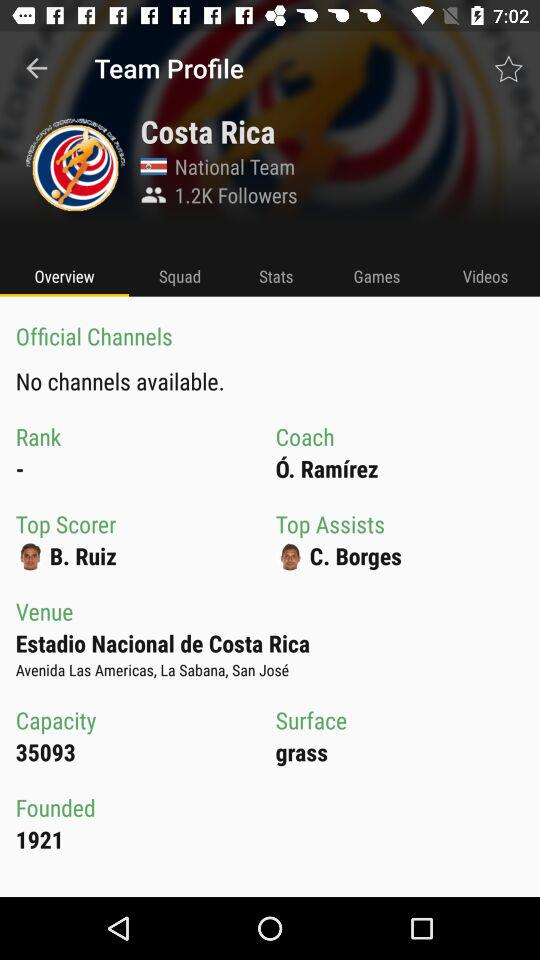When was it founded? It was founded in 1921. 